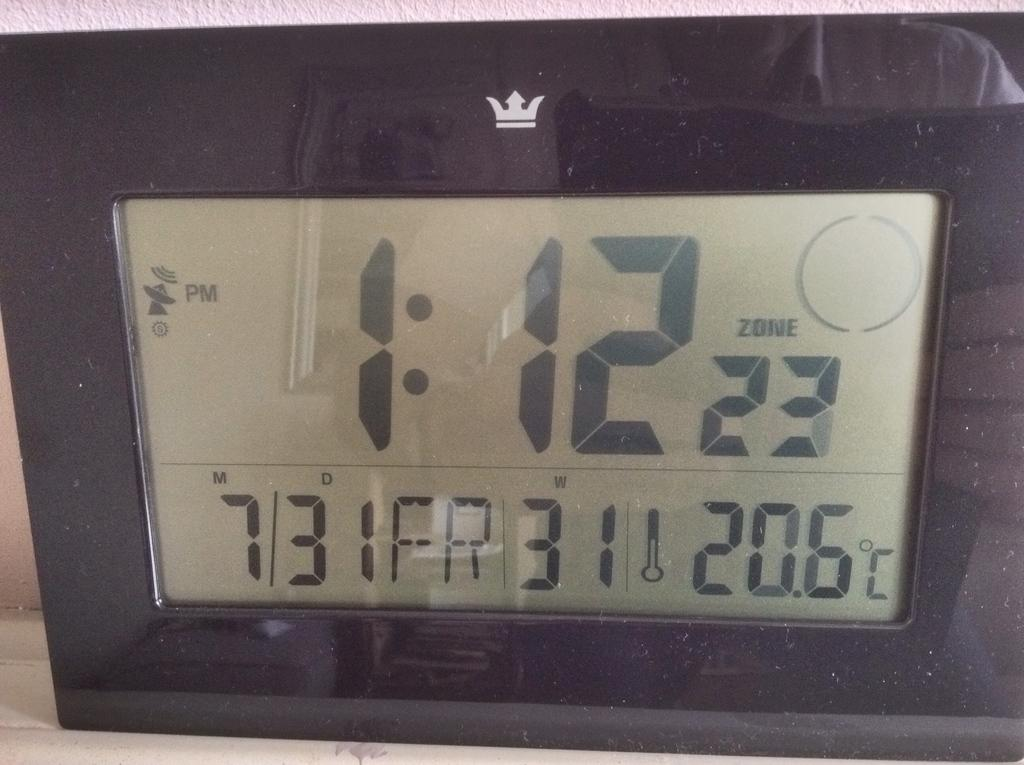<image>
Share a concise interpretation of the image provided. A digital clock displaying a time of 1:12 